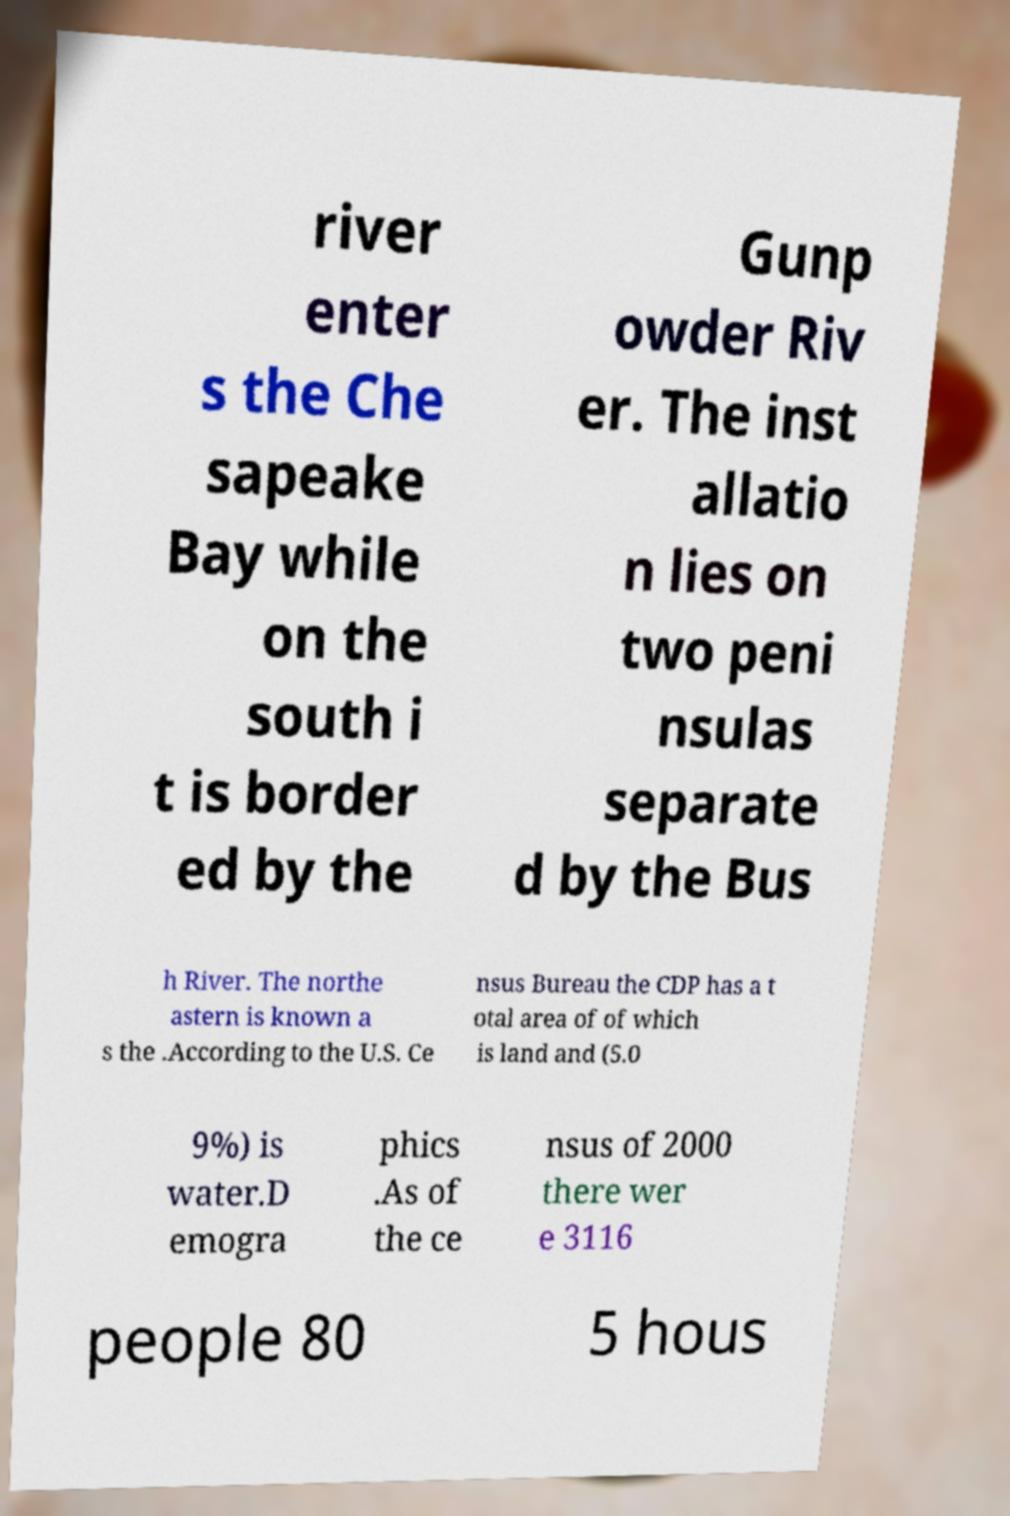Can you accurately transcribe the text from the provided image for me? river enter s the Che sapeake Bay while on the south i t is border ed by the Gunp owder Riv er. The inst allatio n lies on two peni nsulas separate d by the Bus h River. The northe astern is known a s the .According to the U.S. Ce nsus Bureau the CDP has a t otal area of of which is land and (5.0 9%) is water.D emogra phics .As of the ce nsus of 2000 there wer e 3116 people 80 5 hous 